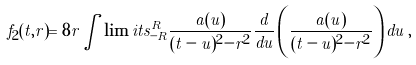Convert formula to latex. <formula><loc_0><loc_0><loc_500><loc_500>f _ { 2 } ( t , r ) = 8 r \int \lim i t s _ { - R } ^ { R } \frac { a ( u ) } { ( t - u ) ^ { 2 } - r ^ { 2 } } \frac { d } { d u } \left ( \frac { a ( u ) } { ( t - u ) ^ { 2 } - r ^ { 2 } } \right ) d u \, ,</formula> 